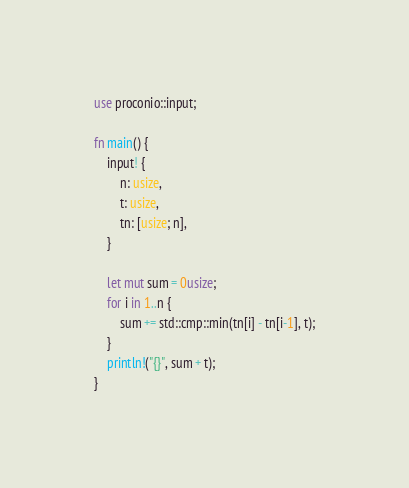<code> <loc_0><loc_0><loc_500><loc_500><_Rust_>use proconio::input;

fn main() {
	input! {
		n: usize,
		t: usize,
		tn: [usize; n],
	}

	let mut sum = 0usize;
	for i in 1..n {
		sum += std::cmp::min(tn[i] - tn[i-1], t);
	}
	println!("{}", sum + t);
}
</code> 